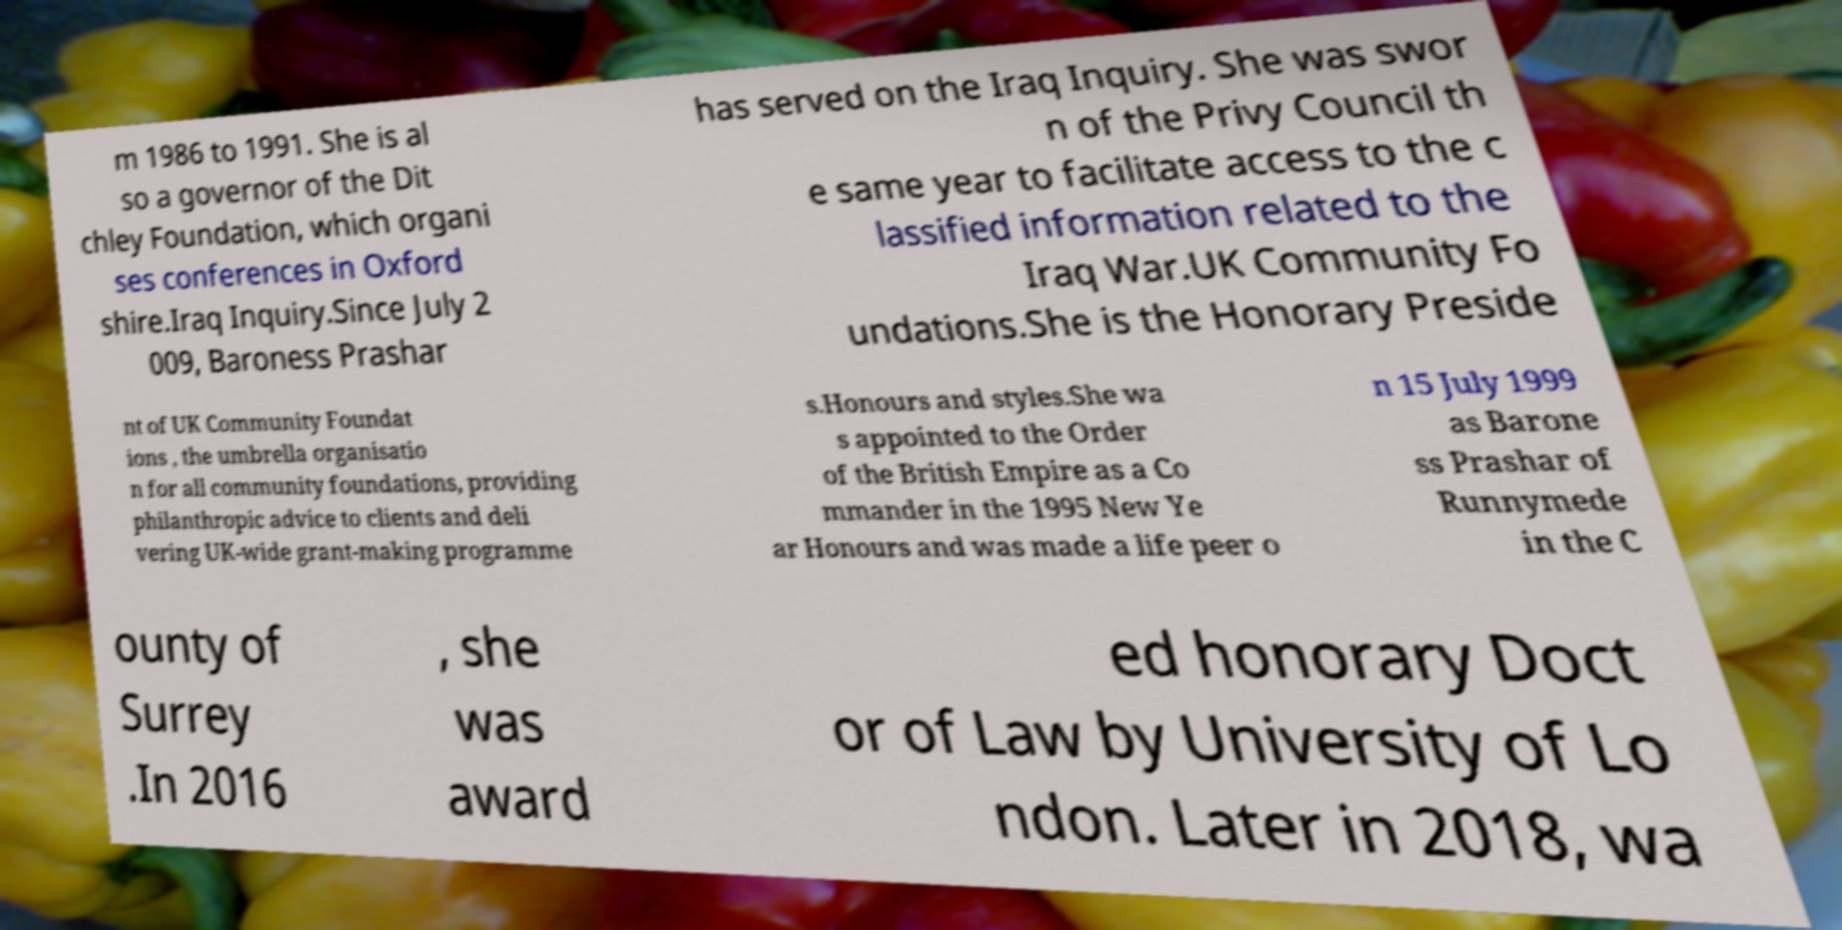I need the written content from this picture converted into text. Can you do that? m 1986 to 1991. She is al so a governor of the Dit chley Foundation, which organi ses conferences in Oxford shire.Iraq Inquiry.Since July 2 009, Baroness Prashar has served on the Iraq Inquiry. She was swor n of the Privy Council th e same year to facilitate access to the c lassified information related to the Iraq War.UK Community Fo undations.She is the Honorary Preside nt of UK Community Foundat ions , the umbrella organisatio n for all community foundations, providing philanthropic advice to clients and deli vering UK-wide grant-making programme s.Honours and styles.She wa s appointed to the Order of the British Empire as a Co mmander in the 1995 New Ye ar Honours and was made a life peer o n 15 July 1999 as Barone ss Prashar of Runnymede in the C ounty of Surrey .In 2016 , she was award ed honorary Doct or of Law by University of Lo ndon. Later in 2018, wa 